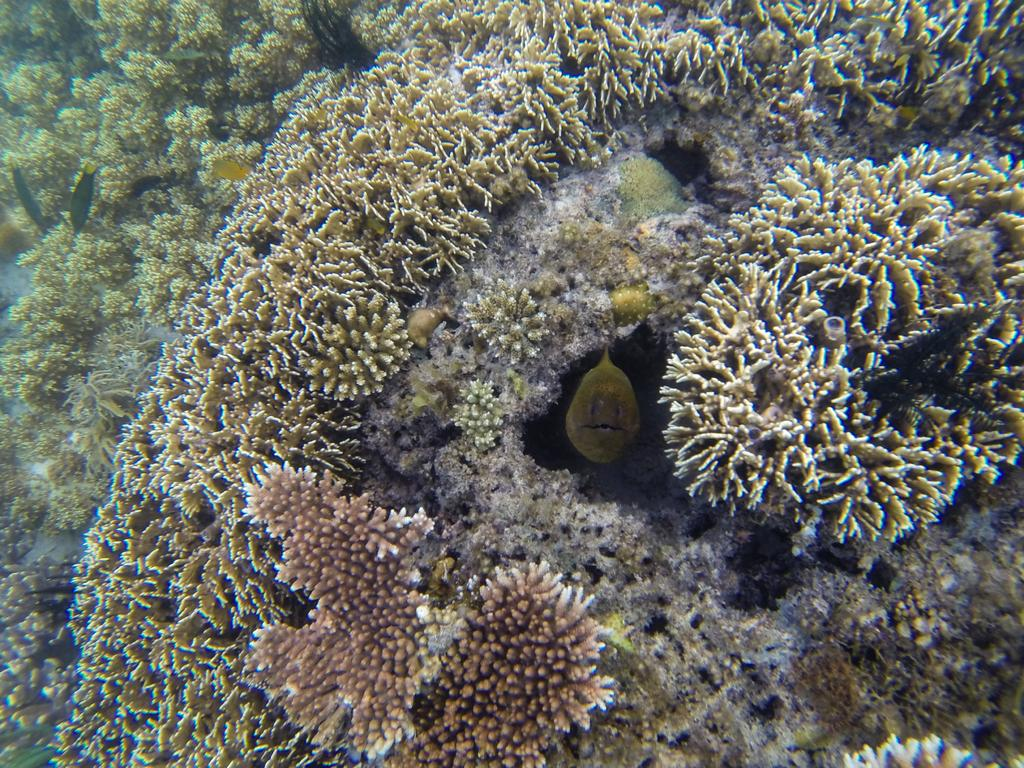What type of plants can be seen in the image? There are aquatic plants in the image. What type of arch can be seen in the image? There is no arch present in the image; it features aquatic plants. What type of humor is depicted in the image? There is no humor depicted in the image; it features aquatic plants. 